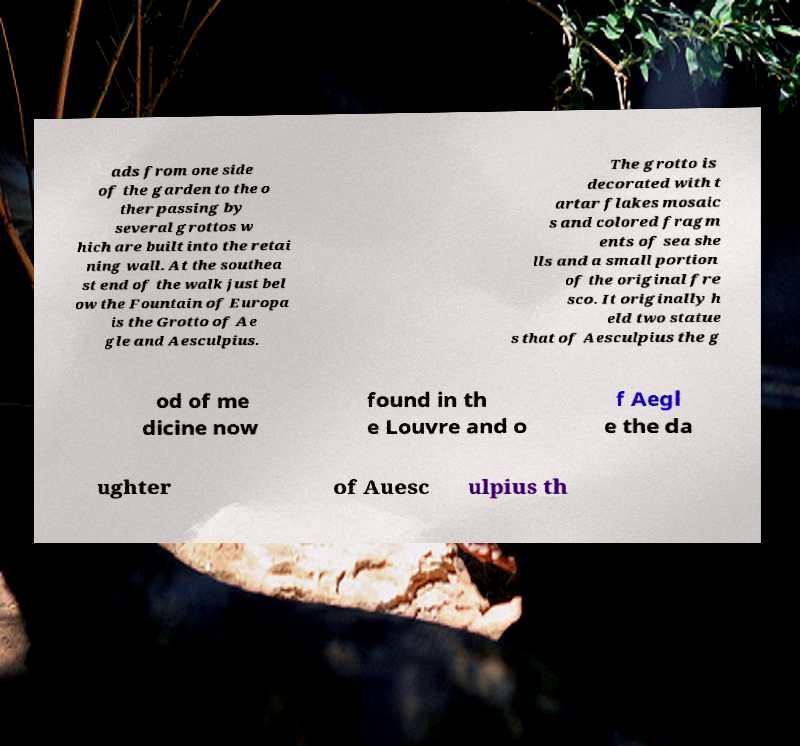Can you accurately transcribe the text from the provided image for me? ads from one side of the garden to the o ther passing by several grottos w hich are built into the retai ning wall. At the southea st end of the walk just bel ow the Fountain of Europa is the Grotto of Ae gle and Aesculpius. The grotto is decorated with t artar flakes mosaic s and colored fragm ents of sea she lls and a small portion of the original fre sco. It originally h eld two statue s that of Aesculpius the g od of me dicine now found in th e Louvre and o f Aegl e the da ughter of Auesc ulpius th 